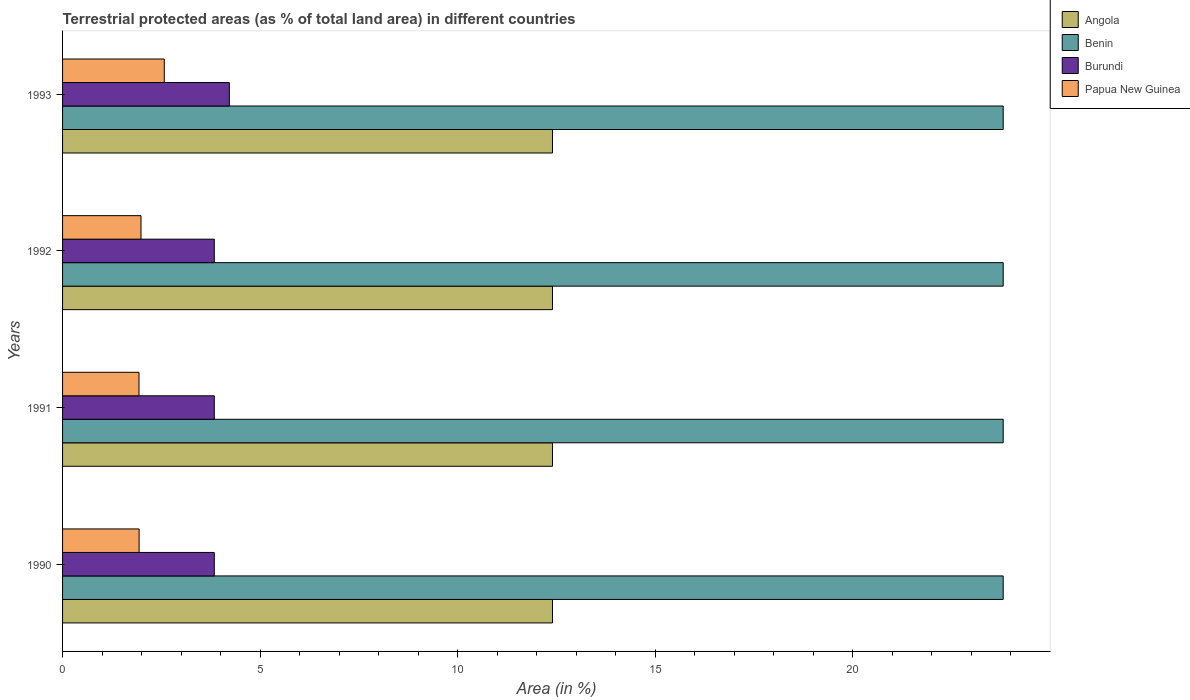Are the number of bars per tick equal to the number of legend labels?
Your response must be concise. Yes. How many bars are there on the 2nd tick from the top?
Offer a very short reply. 4. How many bars are there on the 2nd tick from the bottom?
Provide a succinct answer. 4. In how many cases, is the number of bars for a given year not equal to the number of legend labels?
Offer a terse response. 0. What is the percentage of terrestrial protected land in Angola in 1990?
Ensure brevity in your answer.  12.4. Across all years, what is the maximum percentage of terrestrial protected land in Burundi?
Offer a terse response. 4.22. Across all years, what is the minimum percentage of terrestrial protected land in Benin?
Offer a very short reply. 23.81. In which year was the percentage of terrestrial protected land in Benin minimum?
Your response must be concise. 1991. What is the total percentage of terrestrial protected land in Papua New Guinea in the graph?
Your answer should be very brief. 8.43. What is the difference between the percentage of terrestrial protected land in Burundi in 1990 and that in 1992?
Keep it short and to the point. 2.6717498999850875e-6. What is the difference between the percentage of terrestrial protected land in Angola in 1992 and the percentage of terrestrial protected land in Benin in 1991?
Offer a very short reply. -11.41. What is the average percentage of terrestrial protected land in Papua New Guinea per year?
Provide a short and direct response. 2.11. In the year 1991, what is the difference between the percentage of terrestrial protected land in Papua New Guinea and percentage of terrestrial protected land in Angola?
Your answer should be very brief. -10.47. In how many years, is the percentage of terrestrial protected land in Angola greater than 16 %?
Make the answer very short. 0. What is the ratio of the percentage of terrestrial protected land in Benin in 1990 to that in 1991?
Provide a succinct answer. 1. Is the percentage of terrestrial protected land in Burundi in 1992 less than that in 1993?
Keep it short and to the point. Yes. What is the difference between the highest and the second highest percentage of terrestrial protected land in Benin?
Provide a short and direct response. 1.406299989170634e-5. What is the difference between the highest and the lowest percentage of terrestrial protected land in Benin?
Your answer should be compact. 1.406299989170634e-5. In how many years, is the percentage of terrestrial protected land in Angola greater than the average percentage of terrestrial protected land in Angola taken over all years?
Keep it short and to the point. 1. Is it the case that in every year, the sum of the percentage of terrestrial protected land in Angola and percentage of terrestrial protected land in Papua New Guinea is greater than the sum of percentage of terrestrial protected land in Benin and percentage of terrestrial protected land in Burundi?
Offer a terse response. No. What does the 4th bar from the top in 1991 represents?
Your response must be concise. Angola. What does the 4th bar from the bottom in 1993 represents?
Provide a short and direct response. Papua New Guinea. Is it the case that in every year, the sum of the percentage of terrestrial protected land in Burundi and percentage of terrestrial protected land in Angola is greater than the percentage of terrestrial protected land in Benin?
Offer a terse response. No. How many bars are there?
Your answer should be very brief. 16. Are all the bars in the graph horizontal?
Provide a short and direct response. Yes. How many years are there in the graph?
Offer a very short reply. 4. What is the difference between two consecutive major ticks on the X-axis?
Ensure brevity in your answer.  5. Does the graph contain any zero values?
Give a very brief answer. No. Where does the legend appear in the graph?
Provide a short and direct response. Top right. What is the title of the graph?
Provide a succinct answer. Terrestrial protected areas (as % of total land area) in different countries. Does "Albania" appear as one of the legend labels in the graph?
Keep it short and to the point. No. What is the label or title of the X-axis?
Provide a short and direct response. Area (in %). What is the label or title of the Y-axis?
Give a very brief answer. Years. What is the Area (in %) in Angola in 1990?
Give a very brief answer. 12.4. What is the Area (in %) of Benin in 1990?
Provide a succinct answer. 23.81. What is the Area (in %) in Burundi in 1990?
Make the answer very short. 3.84. What is the Area (in %) of Papua New Guinea in 1990?
Your response must be concise. 1.94. What is the Area (in %) in Angola in 1991?
Your answer should be very brief. 12.4. What is the Area (in %) in Benin in 1991?
Offer a very short reply. 23.81. What is the Area (in %) in Burundi in 1991?
Give a very brief answer. 3.84. What is the Area (in %) of Papua New Guinea in 1991?
Make the answer very short. 1.93. What is the Area (in %) of Angola in 1992?
Keep it short and to the point. 12.4. What is the Area (in %) in Benin in 1992?
Your answer should be compact. 23.81. What is the Area (in %) in Burundi in 1992?
Provide a succinct answer. 3.84. What is the Area (in %) of Papua New Guinea in 1992?
Your response must be concise. 1.99. What is the Area (in %) of Angola in 1993?
Your response must be concise. 12.4. What is the Area (in %) in Benin in 1993?
Your response must be concise. 23.81. What is the Area (in %) in Burundi in 1993?
Keep it short and to the point. 4.22. What is the Area (in %) in Papua New Guinea in 1993?
Offer a terse response. 2.57. Across all years, what is the maximum Area (in %) in Angola?
Keep it short and to the point. 12.4. Across all years, what is the maximum Area (in %) in Benin?
Offer a very short reply. 23.81. Across all years, what is the maximum Area (in %) in Burundi?
Ensure brevity in your answer.  4.22. Across all years, what is the maximum Area (in %) of Papua New Guinea?
Your answer should be compact. 2.57. Across all years, what is the minimum Area (in %) in Angola?
Your answer should be compact. 12.4. Across all years, what is the minimum Area (in %) in Benin?
Your answer should be very brief. 23.81. Across all years, what is the minimum Area (in %) in Burundi?
Your answer should be very brief. 3.84. Across all years, what is the minimum Area (in %) in Papua New Guinea?
Keep it short and to the point. 1.93. What is the total Area (in %) of Angola in the graph?
Ensure brevity in your answer.  49.6. What is the total Area (in %) of Benin in the graph?
Your answer should be compact. 95.23. What is the total Area (in %) in Burundi in the graph?
Your response must be concise. 15.74. What is the total Area (in %) in Papua New Guinea in the graph?
Make the answer very short. 8.43. What is the difference between the Area (in %) in Angola in 1990 and that in 1991?
Your answer should be very brief. 0. What is the difference between the Area (in %) of Burundi in 1990 and that in 1991?
Make the answer very short. 0. What is the difference between the Area (in %) in Papua New Guinea in 1990 and that in 1991?
Provide a succinct answer. 0. What is the difference between the Area (in %) of Angola in 1990 and that in 1992?
Ensure brevity in your answer.  0. What is the difference between the Area (in %) in Burundi in 1990 and that in 1992?
Offer a terse response. 0. What is the difference between the Area (in %) in Papua New Guinea in 1990 and that in 1992?
Give a very brief answer. -0.05. What is the difference between the Area (in %) of Benin in 1990 and that in 1993?
Offer a terse response. 0. What is the difference between the Area (in %) of Burundi in 1990 and that in 1993?
Give a very brief answer. -0.38. What is the difference between the Area (in %) in Papua New Guinea in 1990 and that in 1993?
Provide a succinct answer. -0.64. What is the difference between the Area (in %) of Angola in 1991 and that in 1992?
Your answer should be compact. 0. What is the difference between the Area (in %) in Benin in 1991 and that in 1992?
Provide a succinct answer. 0. What is the difference between the Area (in %) in Papua New Guinea in 1991 and that in 1992?
Keep it short and to the point. -0.05. What is the difference between the Area (in %) of Benin in 1991 and that in 1993?
Your answer should be very brief. 0. What is the difference between the Area (in %) in Burundi in 1991 and that in 1993?
Your response must be concise. -0.38. What is the difference between the Area (in %) in Papua New Guinea in 1991 and that in 1993?
Your answer should be very brief. -0.64. What is the difference between the Area (in %) of Burundi in 1992 and that in 1993?
Your answer should be compact. -0.38. What is the difference between the Area (in %) of Papua New Guinea in 1992 and that in 1993?
Your answer should be very brief. -0.59. What is the difference between the Area (in %) in Angola in 1990 and the Area (in %) in Benin in 1991?
Offer a terse response. -11.41. What is the difference between the Area (in %) in Angola in 1990 and the Area (in %) in Burundi in 1991?
Make the answer very short. 8.56. What is the difference between the Area (in %) in Angola in 1990 and the Area (in %) in Papua New Guinea in 1991?
Make the answer very short. 10.47. What is the difference between the Area (in %) of Benin in 1990 and the Area (in %) of Burundi in 1991?
Provide a short and direct response. 19.97. What is the difference between the Area (in %) in Benin in 1990 and the Area (in %) in Papua New Guinea in 1991?
Make the answer very short. 21.87. What is the difference between the Area (in %) in Burundi in 1990 and the Area (in %) in Papua New Guinea in 1991?
Your answer should be compact. 1.91. What is the difference between the Area (in %) in Angola in 1990 and the Area (in %) in Benin in 1992?
Ensure brevity in your answer.  -11.41. What is the difference between the Area (in %) in Angola in 1990 and the Area (in %) in Burundi in 1992?
Offer a very short reply. 8.56. What is the difference between the Area (in %) of Angola in 1990 and the Area (in %) of Papua New Guinea in 1992?
Give a very brief answer. 10.41. What is the difference between the Area (in %) of Benin in 1990 and the Area (in %) of Burundi in 1992?
Your answer should be compact. 19.97. What is the difference between the Area (in %) in Benin in 1990 and the Area (in %) in Papua New Guinea in 1992?
Your answer should be very brief. 21.82. What is the difference between the Area (in %) in Burundi in 1990 and the Area (in %) in Papua New Guinea in 1992?
Your answer should be compact. 1.85. What is the difference between the Area (in %) in Angola in 1990 and the Area (in %) in Benin in 1993?
Give a very brief answer. -11.41. What is the difference between the Area (in %) in Angola in 1990 and the Area (in %) in Burundi in 1993?
Ensure brevity in your answer.  8.18. What is the difference between the Area (in %) in Angola in 1990 and the Area (in %) in Papua New Guinea in 1993?
Ensure brevity in your answer.  9.83. What is the difference between the Area (in %) of Benin in 1990 and the Area (in %) of Burundi in 1993?
Your answer should be compact. 19.59. What is the difference between the Area (in %) in Benin in 1990 and the Area (in %) in Papua New Guinea in 1993?
Give a very brief answer. 21.23. What is the difference between the Area (in %) in Burundi in 1990 and the Area (in %) in Papua New Guinea in 1993?
Your answer should be compact. 1.27. What is the difference between the Area (in %) of Angola in 1991 and the Area (in %) of Benin in 1992?
Your answer should be compact. -11.41. What is the difference between the Area (in %) in Angola in 1991 and the Area (in %) in Burundi in 1992?
Offer a terse response. 8.56. What is the difference between the Area (in %) in Angola in 1991 and the Area (in %) in Papua New Guinea in 1992?
Make the answer very short. 10.41. What is the difference between the Area (in %) in Benin in 1991 and the Area (in %) in Burundi in 1992?
Offer a terse response. 19.97. What is the difference between the Area (in %) of Benin in 1991 and the Area (in %) of Papua New Guinea in 1992?
Your answer should be very brief. 21.82. What is the difference between the Area (in %) of Burundi in 1991 and the Area (in %) of Papua New Guinea in 1992?
Provide a short and direct response. 1.85. What is the difference between the Area (in %) of Angola in 1991 and the Area (in %) of Benin in 1993?
Your response must be concise. -11.41. What is the difference between the Area (in %) in Angola in 1991 and the Area (in %) in Burundi in 1993?
Your answer should be very brief. 8.18. What is the difference between the Area (in %) of Angola in 1991 and the Area (in %) of Papua New Guinea in 1993?
Your answer should be very brief. 9.83. What is the difference between the Area (in %) of Benin in 1991 and the Area (in %) of Burundi in 1993?
Ensure brevity in your answer.  19.59. What is the difference between the Area (in %) of Benin in 1991 and the Area (in %) of Papua New Guinea in 1993?
Provide a succinct answer. 21.23. What is the difference between the Area (in %) of Burundi in 1991 and the Area (in %) of Papua New Guinea in 1993?
Provide a short and direct response. 1.27. What is the difference between the Area (in %) of Angola in 1992 and the Area (in %) of Benin in 1993?
Provide a short and direct response. -11.41. What is the difference between the Area (in %) of Angola in 1992 and the Area (in %) of Burundi in 1993?
Provide a succinct answer. 8.18. What is the difference between the Area (in %) of Angola in 1992 and the Area (in %) of Papua New Guinea in 1993?
Your answer should be very brief. 9.83. What is the difference between the Area (in %) in Benin in 1992 and the Area (in %) in Burundi in 1993?
Make the answer very short. 19.59. What is the difference between the Area (in %) in Benin in 1992 and the Area (in %) in Papua New Guinea in 1993?
Your response must be concise. 21.23. What is the difference between the Area (in %) of Burundi in 1992 and the Area (in %) of Papua New Guinea in 1993?
Offer a very short reply. 1.27. What is the average Area (in %) in Angola per year?
Offer a very short reply. 12.4. What is the average Area (in %) in Benin per year?
Your answer should be compact. 23.81. What is the average Area (in %) in Burundi per year?
Offer a terse response. 3.94. What is the average Area (in %) in Papua New Guinea per year?
Your response must be concise. 2.11. In the year 1990, what is the difference between the Area (in %) in Angola and Area (in %) in Benin?
Give a very brief answer. -11.41. In the year 1990, what is the difference between the Area (in %) of Angola and Area (in %) of Burundi?
Offer a very short reply. 8.56. In the year 1990, what is the difference between the Area (in %) in Angola and Area (in %) in Papua New Guinea?
Ensure brevity in your answer.  10.46. In the year 1990, what is the difference between the Area (in %) in Benin and Area (in %) in Burundi?
Your response must be concise. 19.97. In the year 1990, what is the difference between the Area (in %) of Benin and Area (in %) of Papua New Guinea?
Ensure brevity in your answer.  21.87. In the year 1990, what is the difference between the Area (in %) in Burundi and Area (in %) in Papua New Guinea?
Offer a terse response. 1.9. In the year 1991, what is the difference between the Area (in %) of Angola and Area (in %) of Benin?
Ensure brevity in your answer.  -11.41. In the year 1991, what is the difference between the Area (in %) of Angola and Area (in %) of Burundi?
Ensure brevity in your answer.  8.56. In the year 1991, what is the difference between the Area (in %) in Angola and Area (in %) in Papua New Guinea?
Your response must be concise. 10.47. In the year 1991, what is the difference between the Area (in %) in Benin and Area (in %) in Burundi?
Your response must be concise. 19.97. In the year 1991, what is the difference between the Area (in %) in Benin and Area (in %) in Papua New Guinea?
Your answer should be compact. 21.87. In the year 1991, what is the difference between the Area (in %) in Burundi and Area (in %) in Papua New Guinea?
Give a very brief answer. 1.91. In the year 1992, what is the difference between the Area (in %) in Angola and Area (in %) in Benin?
Provide a short and direct response. -11.41. In the year 1992, what is the difference between the Area (in %) in Angola and Area (in %) in Burundi?
Make the answer very short. 8.56. In the year 1992, what is the difference between the Area (in %) of Angola and Area (in %) of Papua New Guinea?
Make the answer very short. 10.41. In the year 1992, what is the difference between the Area (in %) in Benin and Area (in %) in Burundi?
Make the answer very short. 19.97. In the year 1992, what is the difference between the Area (in %) of Benin and Area (in %) of Papua New Guinea?
Provide a short and direct response. 21.82. In the year 1992, what is the difference between the Area (in %) of Burundi and Area (in %) of Papua New Guinea?
Keep it short and to the point. 1.85. In the year 1993, what is the difference between the Area (in %) of Angola and Area (in %) of Benin?
Offer a terse response. -11.41. In the year 1993, what is the difference between the Area (in %) of Angola and Area (in %) of Burundi?
Offer a terse response. 8.18. In the year 1993, what is the difference between the Area (in %) of Angola and Area (in %) of Papua New Guinea?
Offer a terse response. 9.83. In the year 1993, what is the difference between the Area (in %) of Benin and Area (in %) of Burundi?
Provide a short and direct response. 19.59. In the year 1993, what is the difference between the Area (in %) in Benin and Area (in %) in Papua New Guinea?
Keep it short and to the point. 21.23. In the year 1993, what is the difference between the Area (in %) of Burundi and Area (in %) of Papua New Guinea?
Your answer should be compact. 1.65. What is the ratio of the Area (in %) of Angola in 1990 to that in 1991?
Offer a very short reply. 1. What is the ratio of the Area (in %) of Benin in 1990 to that in 1991?
Your answer should be compact. 1. What is the ratio of the Area (in %) in Papua New Guinea in 1990 to that in 1991?
Ensure brevity in your answer.  1. What is the ratio of the Area (in %) of Burundi in 1990 to that in 1992?
Ensure brevity in your answer.  1. What is the ratio of the Area (in %) in Papua New Guinea in 1990 to that in 1992?
Your answer should be compact. 0.98. What is the ratio of the Area (in %) in Benin in 1990 to that in 1993?
Provide a short and direct response. 1. What is the ratio of the Area (in %) in Burundi in 1990 to that in 1993?
Your response must be concise. 0.91. What is the ratio of the Area (in %) in Papua New Guinea in 1990 to that in 1993?
Provide a succinct answer. 0.75. What is the ratio of the Area (in %) in Angola in 1991 to that in 1992?
Your answer should be very brief. 1. What is the ratio of the Area (in %) of Papua New Guinea in 1991 to that in 1992?
Give a very brief answer. 0.97. What is the ratio of the Area (in %) of Benin in 1991 to that in 1993?
Provide a short and direct response. 1. What is the ratio of the Area (in %) in Burundi in 1991 to that in 1993?
Your answer should be very brief. 0.91. What is the ratio of the Area (in %) in Papua New Guinea in 1991 to that in 1993?
Keep it short and to the point. 0.75. What is the ratio of the Area (in %) of Angola in 1992 to that in 1993?
Ensure brevity in your answer.  1. What is the ratio of the Area (in %) in Burundi in 1992 to that in 1993?
Keep it short and to the point. 0.91. What is the ratio of the Area (in %) of Papua New Guinea in 1992 to that in 1993?
Give a very brief answer. 0.77. What is the difference between the highest and the second highest Area (in %) of Benin?
Give a very brief answer. 0. What is the difference between the highest and the second highest Area (in %) in Burundi?
Keep it short and to the point. 0.38. What is the difference between the highest and the second highest Area (in %) in Papua New Guinea?
Provide a succinct answer. 0.59. What is the difference between the highest and the lowest Area (in %) in Burundi?
Provide a succinct answer. 0.38. What is the difference between the highest and the lowest Area (in %) of Papua New Guinea?
Your answer should be very brief. 0.64. 